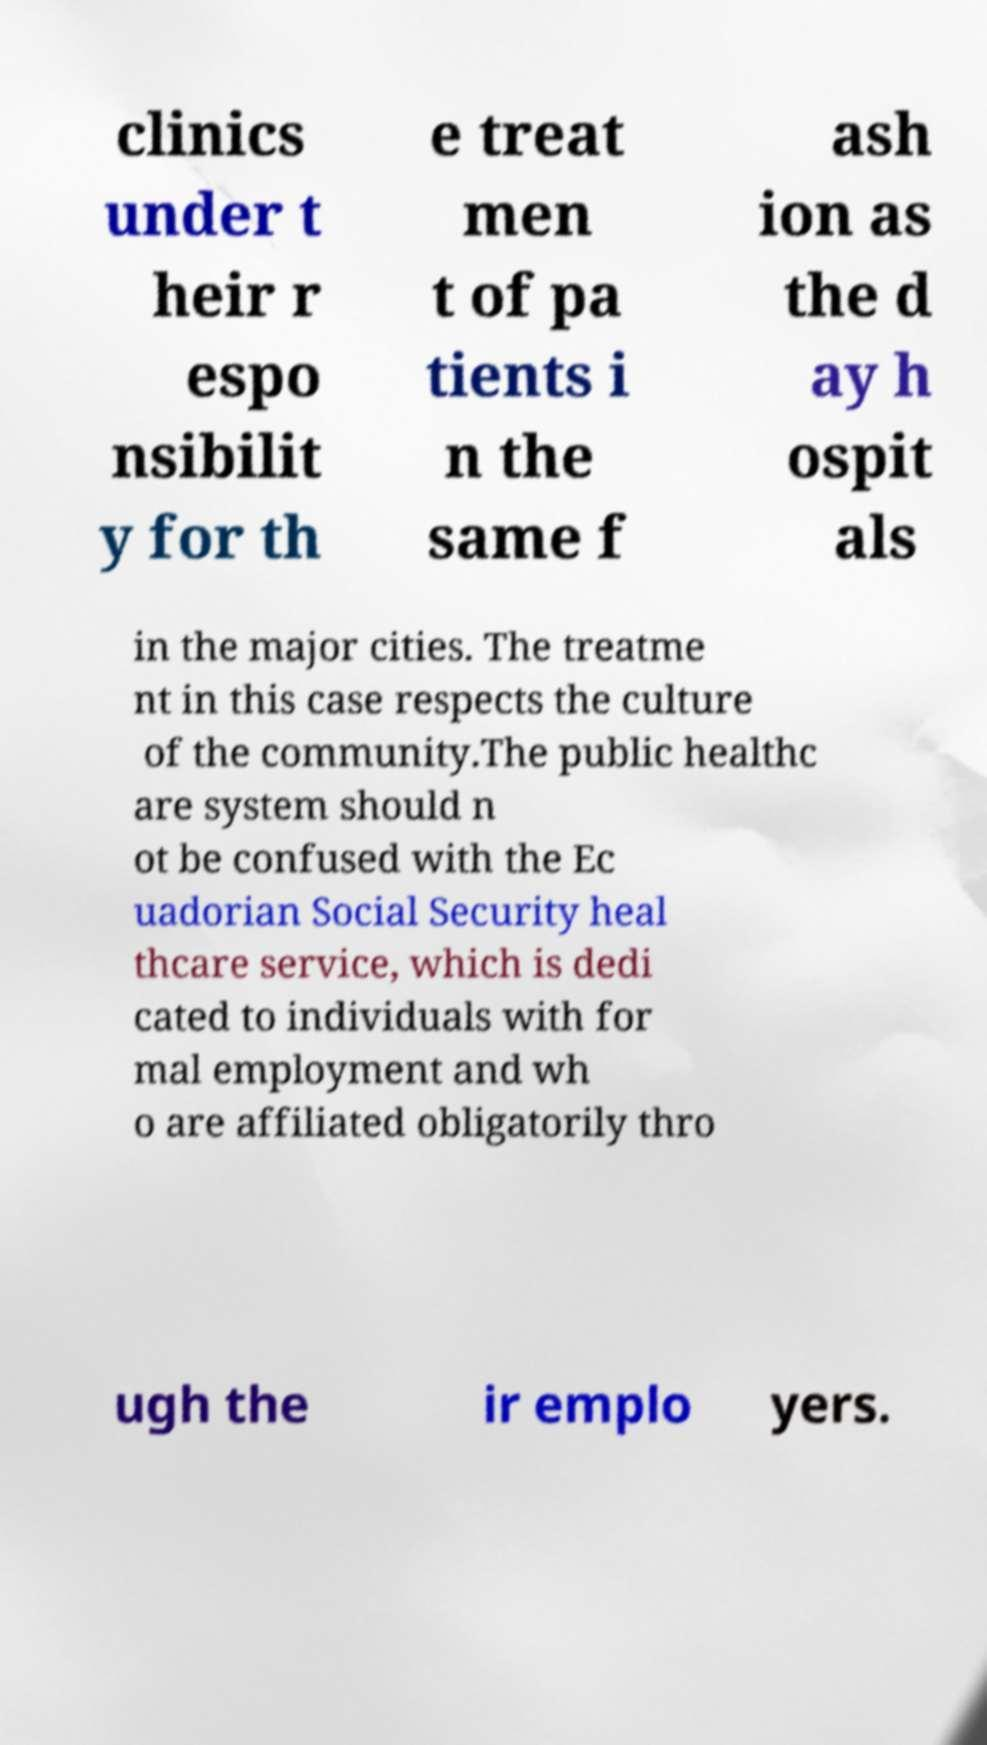Please read and relay the text visible in this image. What does it say? clinics under t heir r espo nsibilit y for th e treat men t of pa tients i n the same f ash ion as the d ay h ospit als in the major cities. The treatme nt in this case respects the culture of the community.The public healthc are system should n ot be confused with the Ec uadorian Social Security heal thcare service, which is dedi cated to individuals with for mal employment and wh o are affiliated obligatorily thro ugh the ir emplo yers. 